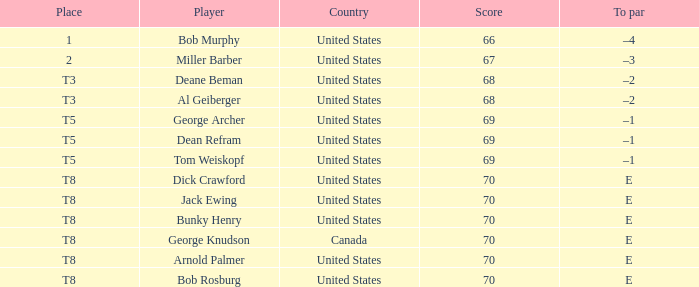Where did Bob Murphy of the United States place? 1.0. 